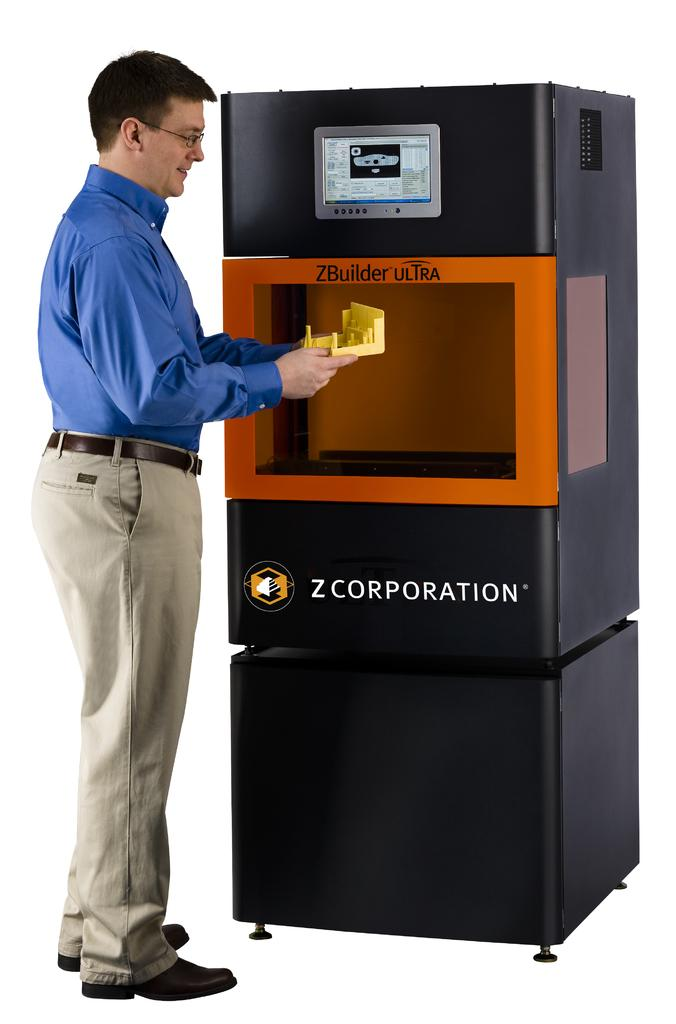<image>
Describe the image concisely. A man stands outside a ZBuilder Ultra holding a product. 